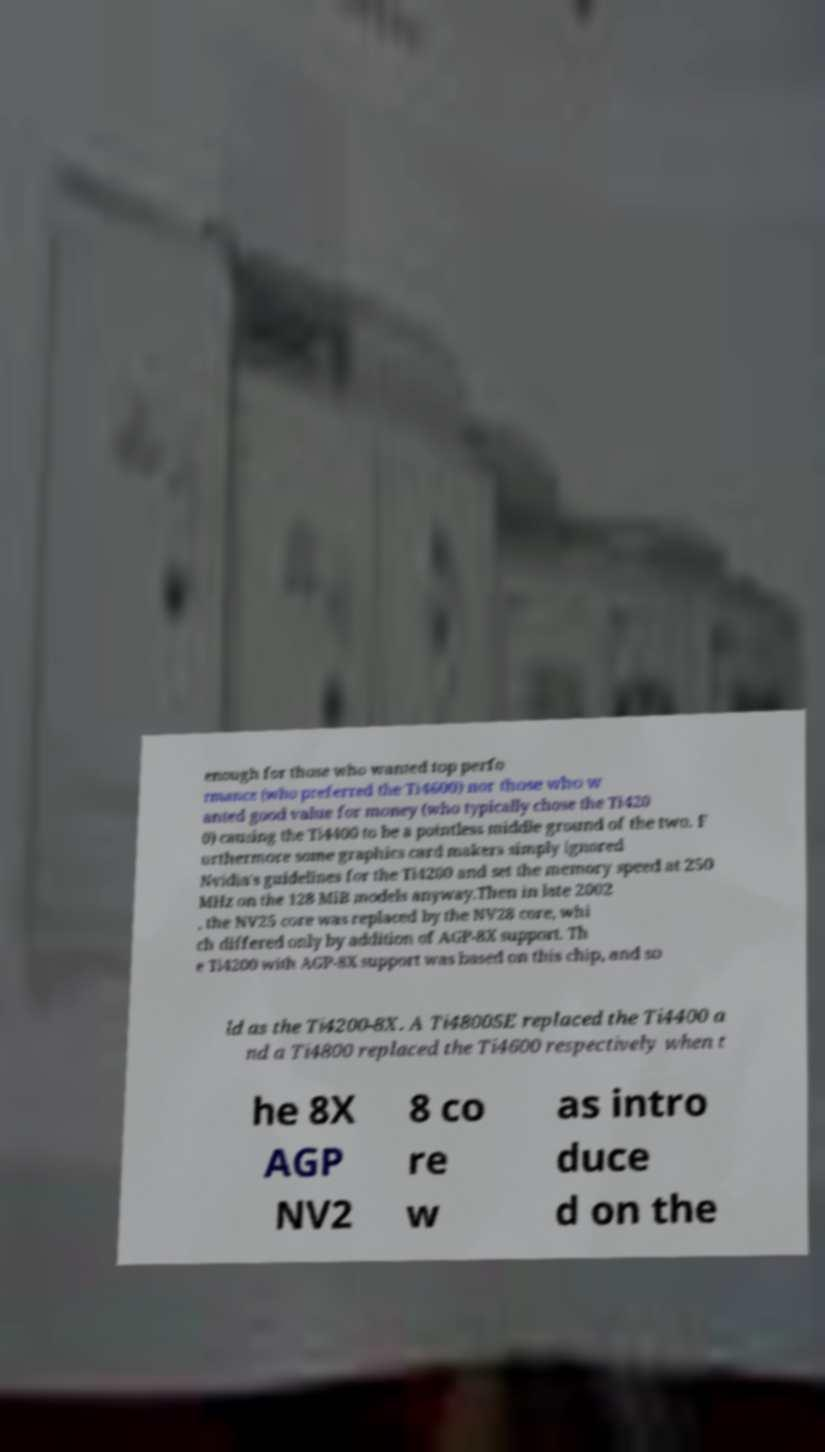Could you assist in decoding the text presented in this image and type it out clearly? enough for those who wanted top perfo rmance (who preferred the Ti4600) nor those who w anted good value for money (who typically chose the Ti420 0) causing the Ti4400 to be a pointless middle ground of the two. F urthermore some graphics card makers simply ignored Nvidia's guidelines for the Ti4200 and set the memory speed at 250 MHz on the 128 MiB models anyway.Then in late 2002 , the NV25 core was replaced by the NV28 core, whi ch differed only by addition of AGP-8X support. Th e Ti4200 with AGP-8X support was based on this chip, and so ld as the Ti4200-8X. A Ti4800SE replaced the Ti4400 a nd a Ti4800 replaced the Ti4600 respectively when t he 8X AGP NV2 8 co re w as intro duce d on the 